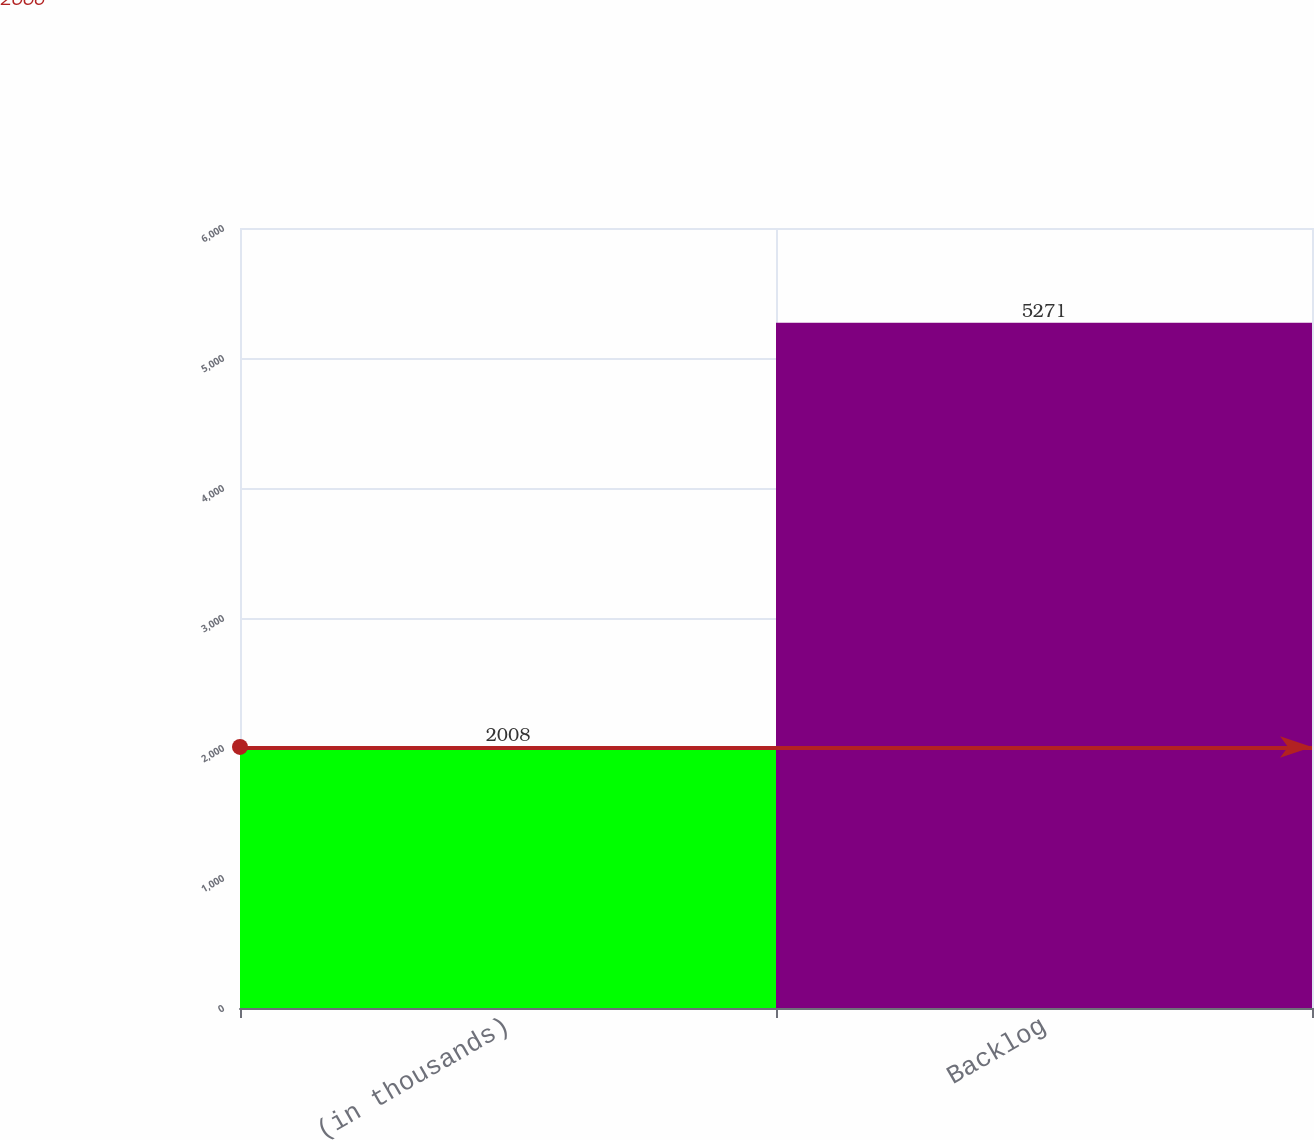<chart> <loc_0><loc_0><loc_500><loc_500><bar_chart><fcel>(in thousands)<fcel>Backlog<nl><fcel>2008<fcel>5271<nl></chart> 